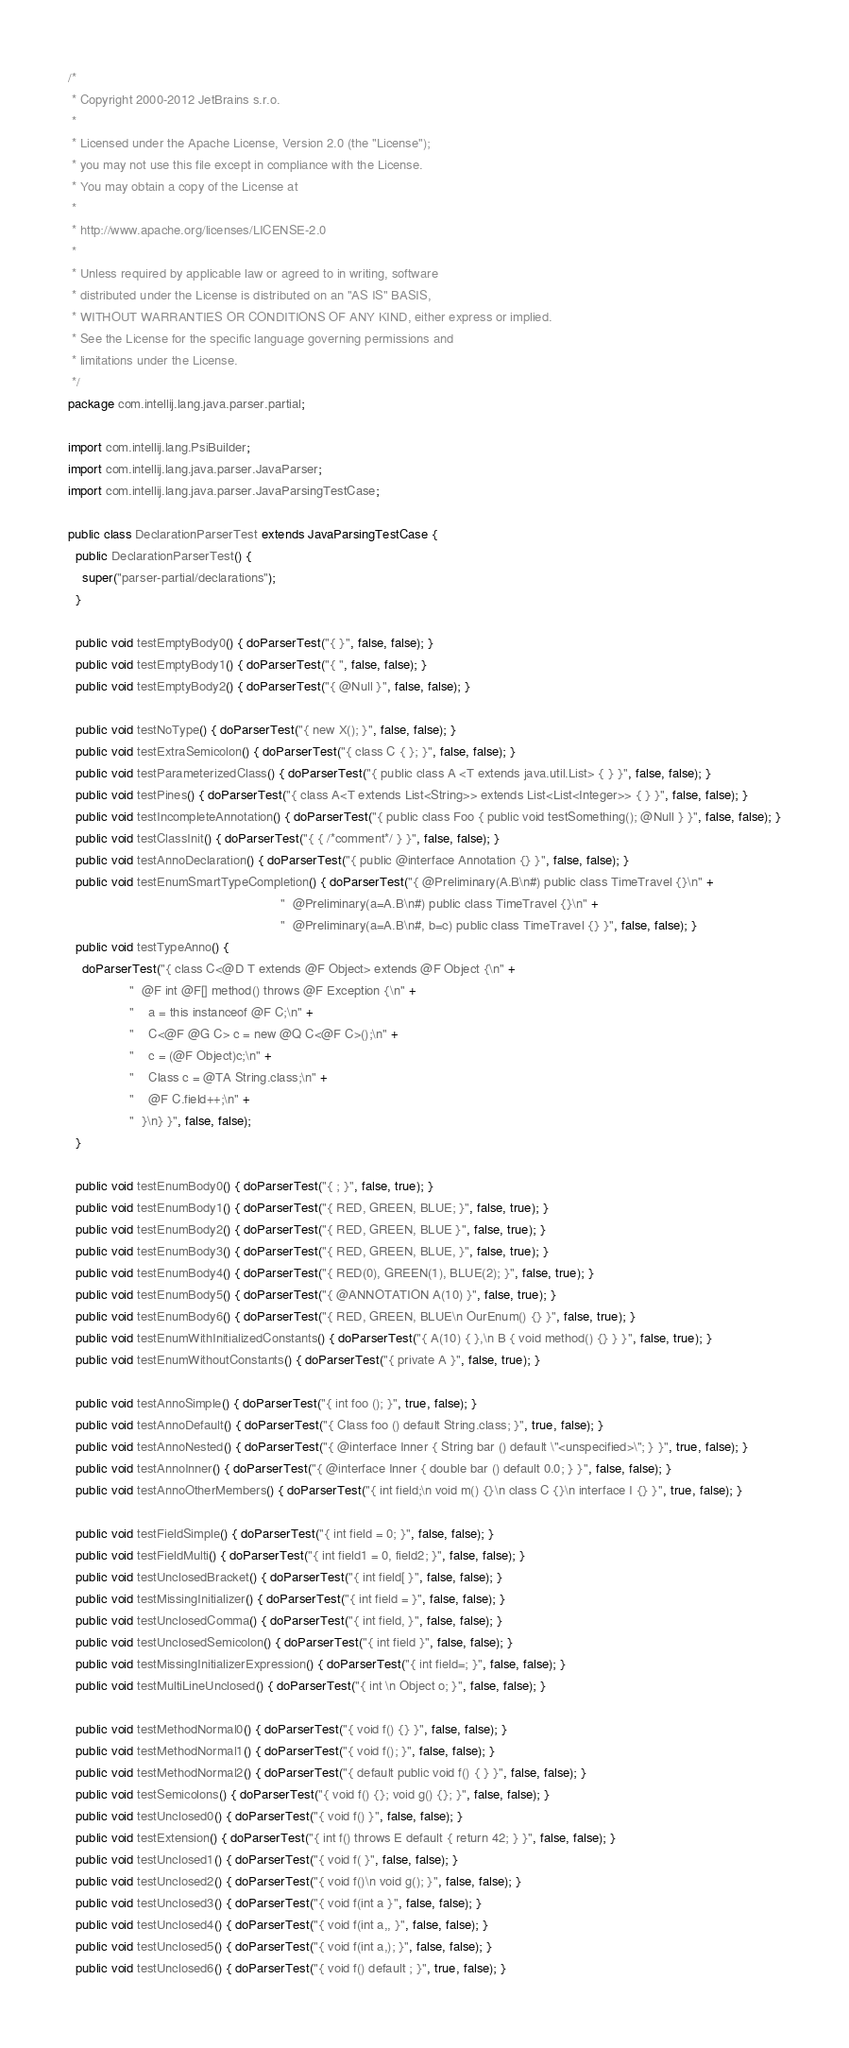<code> <loc_0><loc_0><loc_500><loc_500><_Java_>/*
 * Copyright 2000-2012 JetBrains s.r.o.
 *
 * Licensed under the Apache License, Version 2.0 (the "License");
 * you may not use this file except in compliance with the License.
 * You may obtain a copy of the License at
 *
 * http://www.apache.org/licenses/LICENSE-2.0
 *
 * Unless required by applicable law or agreed to in writing, software
 * distributed under the License is distributed on an "AS IS" BASIS,
 * WITHOUT WARRANTIES OR CONDITIONS OF ANY KIND, either express or implied.
 * See the License for the specific language governing permissions and
 * limitations under the License.
 */
package com.intellij.lang.java.parser.partial;

import com.intellij.lang.PsiBuilder;
import com.intellij.lang.java.parser.JavaParser;
import com.intellij.lang.java.parser.JavaParsingTestCase;

public class DeclarationParserTest extends JavaParsingTestCase {
  public DeclarationParserTest() {
    super("parser-partial/declarations");
  }

  public void testEmptyBody0() { doParserTest("{ }", false, false); }
  public void testEmptyBody1() { doParserTest("{ ", false, false); }
  public void testEmptyBody2() { doParserTest("{ @Null }", false, false); }

  public void testNoType() { doParserTest("{ new X(); }", false, false); }
  public void testExtraSemicolon() { doParserTest("{ class C { }; }", false, false); }
  public void testParameterizedClass() { doParserTest("{ public class A <T extends java.util.List> { } }", false, false); }
  public void testPines() { doParserTest("{ class A<T extends List<String>> extends List<List<Integer>> { } }", false, false); }
  public void testIncompleteAnnotation() { doParserTest("{ public class Foo { public void testSomething(); @Null } }", false, false); }
  public void testClassInit() { doParserTest("{ { /*comment*/ } }", false, false); }
  public void testAnnoDeclaration() { doParserTest("{ public @interface Annotation {} }", false, false); }
  public void testEnumSmartTypeCompletion() { doParserTest("{ @Preliminary(A.B\n#) public class TimeTravel {}\n" +
                                                           "  @Preliminary(a=A.B\n#) public class TimeTravel {}\n" +
                                                           "  @Preliminary(a=A.B\n#, b=c) public class TimeTravel {} }", false, false); }
  public void testTypeAnno() {
    doParserTest("{ class C<@D T extends @F Object> extends @F Object {\n" +
                 "  @F int @F[] method() throws @F Exception {\n" +
                 "    a = this instanceof @F C;\n" +
                 "    C<@F @G C> c = new @Q C<@F C>();\n" +
                 "    c = (@F Object)c;\n" +
                 "    Class c = @TA String.class;\n" +
                 "    @F C.field++;\n" +
                 "  }\n} }", false, false);
  }

  public void testEnumBody0() { doParserTest("{ ; }", false, true); }
  public void testEnumBody1() { doParserTest("{ RED, GREEN, BLUE; }", false, true); }
  public void testEnumBody2() { doParserTest("{ RED, GREEN, BLUE }", false, true); }
  public void testEnumBody3() { doParserTest("{ RED, GREEN, BLUE, }", false, true); }
  public void testEnumBody4() { doParserTest("{ RED(0), GREEN(1), BLUE(2); }", false, true); }
  public void testEnumBody5() { doParserTest("{ @ANNOTATION A(10) }", false, true); }
  public void testEnumBody6() { doParserTest("{ RED, GREEN, BLUE\n OurEnum() {} }", false, true); }
  public void testEnumWithInitializedConstants() { doParserTest("{ A(10) { },\n B { void method() {} } }", false, true); }
  public void testEnumWithoutConstants() { doParserTest("{ private A }", false, true); }

  public void testAnnoSimple() { doParserTest("{ int foo (); }", true, false); }
  public void testAnnoDefault() { doParserTest("{ Class foo () default String.class; }", true, false); }
  public void testAnnoNested() { doParserTest("{ @interface Inner { String bar () default \"<unspecified>\"; } }", true, false); }
  public void testAnnoInner() { doParserTest("{ @interface Inner { double bar () default 0.0; } }", false, false); }
  public void testAnnoOtherMembers() { doParserTest("{ int field;\n void m() {}\n class C {}\n interface I {} }", true, false); }

  public void testFieldSimple() { doParserTest("{ int field = 0; }", false, false); }
  public void testFieldMulti() { doParserTest("{ int field1 = 0, field2; }", false, false); }
  public void testUnclosedBracket() { doParserTest("{ int field[ }", false, false); }
  public void testMissingInitializer() { doParserTest("{ int field = }", false, false); }
  public void testUnclosedComma() { doParserTest("{ int field, }", false, false); }
  public void testUnclosedSemicolon() { doParserTest("{ int field }", false, false); }
  public void testMissingInitializerExpression() { doParserTest("{ int field=; }", false, false); }
  public void testMultiLineUnclosed() { doParserTest("{ int \n Object o; }", false, false); }

  public void testMethodNormal0() { doParserTest("{ void f() {} }", false, false); }
  public void testMethodNormal1() { doParserTest("{ void f(); }", false, false); }
  public void testMethodNormal2() { doParserTest("{ default public void f() { } }", false, false); }
  public void testSemicolons() { doParserTest("{ void f() {}; void g() {}; }", false, false); }
  public void testUnclosed0() { doParserTest("{ void f() }", false, false); }
  public void testExtension() { doParserTest("{ int f() throws E default { return 42; } }", false, false); }
  public void testUnclosed1() { doParserTest("{ void f( }", false, false); }
  public void testUnclosed2() { doParserTest("{ void f()\n void g(); }", false, false); }
  public void testUnclosed3() { doParserTest("{ void f(int a }", false, false); }
  public void testUnclosed4() { doParserTest("{ void f(int a,, }", false, false); }
  public void testUnclosed5() { doParserTest("{ void f(int a,); }", false, false); }
  public void testUnclosed6() { doParserTest("{ void f() default ; }", true, false); }</code> 